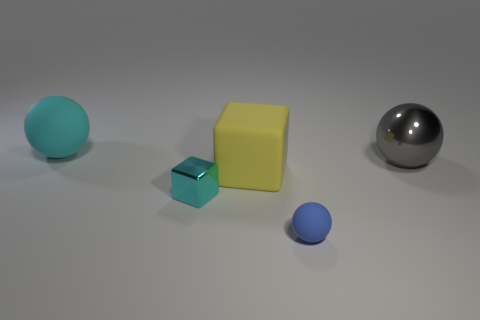Subtract all rubber balls. How many balls are left? 1 Add 2 large gray things. How many objects exist? 7 Subtract all cyan cubes. How many cubes are left? 1 Subtract 2 spheres. How many spheres are left? 1 Subtract all tiny brown matte objects. Subtract all yellow matte things. How many objects are left? 4 Add 3 tiny cyan metal cubes. How many tiny cyan metal cubes are left? 4 Add 5 large cyan things. How many large cyan things exist? 6 Subtract 0 green blocks. How many objects are left? 5 Subtract all cubes. How many objects are left? 3 Subtract all brown cubes. Subtract all brown spheres. How many cubes are left? 2 